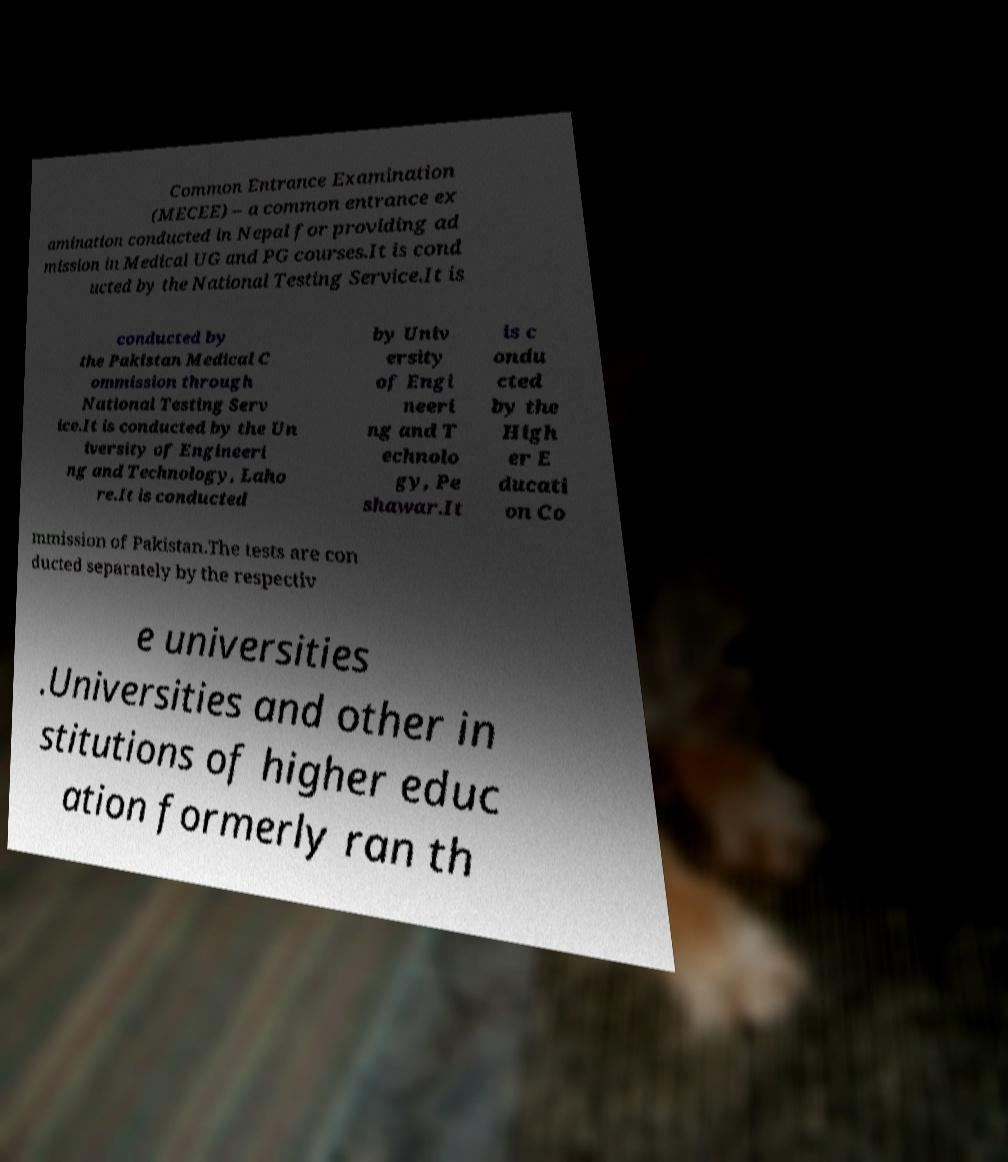I need the written content from this picture converted into text. Can you do that? Common Entrance Examination (MECEE) – a common entrance ex amination conducted in Nepal for providing ad mission in Medical UG and PG courses.It is cond ucted by the National Testing Service.It is conducted by the Pakistan Medical C ommission through National Testing Serv ice.It is conducted by the Un iversity of Engineeri ng and Technology, Laho re.It is conducted by Univ ersity of Engi neeri ng and T echnolo gy, Pe shawar.It is c ondu cted by the High er E ducati on Co mmission of Pakistan.The tests are con ducted separately by the respectiv e universities .Universities and other in stitutions of higher educ ation formerly ran th 